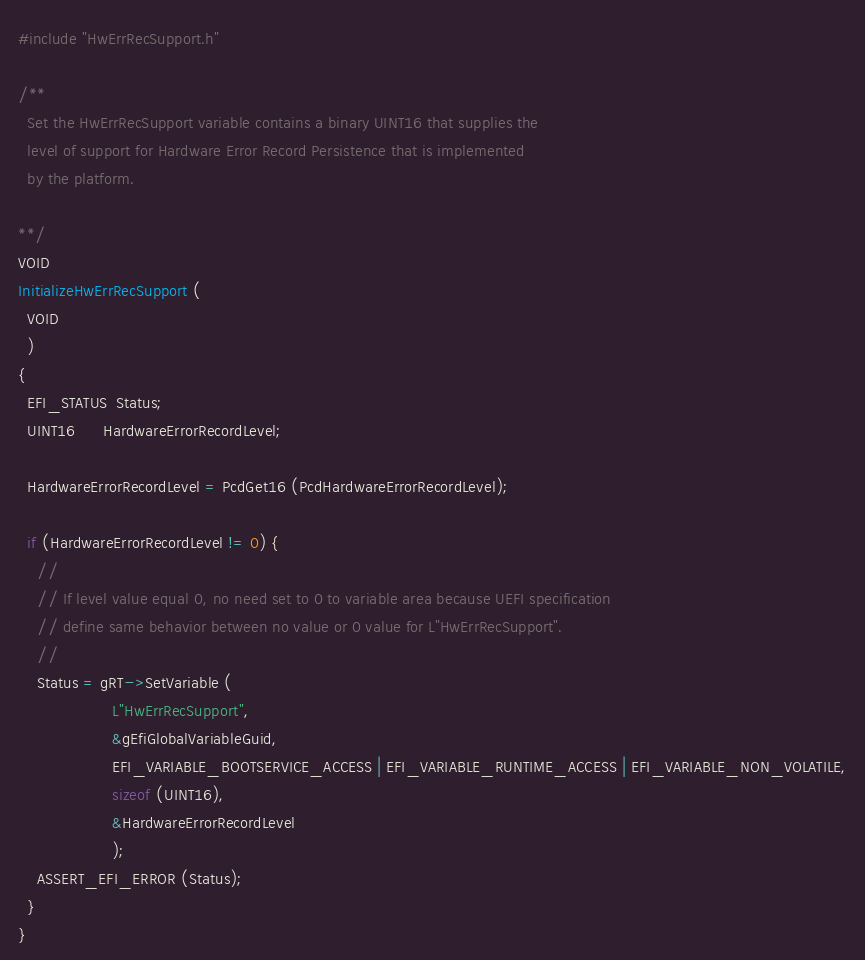<code> <loc_0><loc_0><loc_500><loc_500><_C_>
#include "HwErrRecSupport.h"

/**
  Set the HwErrRecSupport variable contains a binary UINT16 that supplies the
  level of support for Hardware Error Record Persistence that is implemented
  by the platform.

**/
VOID
InitializeHwErrRecSupport (
  VOID
  )
{
  EFI_STATUS  Status;
  UINT16      HardwareErrorRecordLevel;

  HardwareErrorRecordLevel = PcdGet16 (PcdHardwareErrorRecordLevel);

  if (HardwareErrorRecordLevel != 0) {
    //
    // If level value equal 0, no need set to 0 to variable area because UEFI specification
    // define same behavior between no value or 0 value for L"HwErrRecSupport".
    //
    Status = gRT->SetVariable (
                    L"HwErrRecSupport",
                    &gEfiGlobalVariableGuid,
                    EFI_VARIABLE_BOOTSERVICE_ACCESS | EFI_VARIABLE_RUNTIME_ACCESS | EFI_VARIABLE_NON_VOLATILE,
                    sizeof (UINT16),
                    &HardwareErrorRecordLevel
                    );
    ASSERT_EFI_ERROR (Status);
  }
}
</code> 